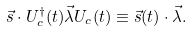<formula> <loc_0><loc_0><loc_500><loc_500>\vec { s } \cdot U ^ { \dagger } _ { c } ( t ) \vec { \lambda } U _ { c } ( t ) \equiv \vec { s } ( t ) \cdot \vec { \lambda } .</formula> 